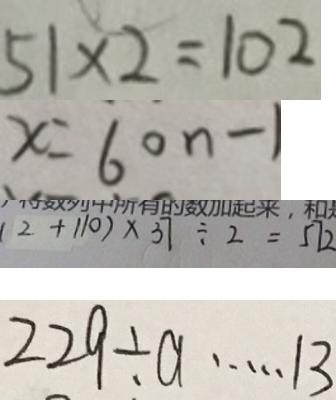<formula> <loc_0><loc_0><loc_500><loc_500>5 1 \times 2 = 1 0 2 
 x = 6 0 n - 1 
 ( 2 + 1 1 0 ) \times 3 7 \div 2 = 5 7 2 
 2 2 9 \div a \cdots 1 3</formula> 